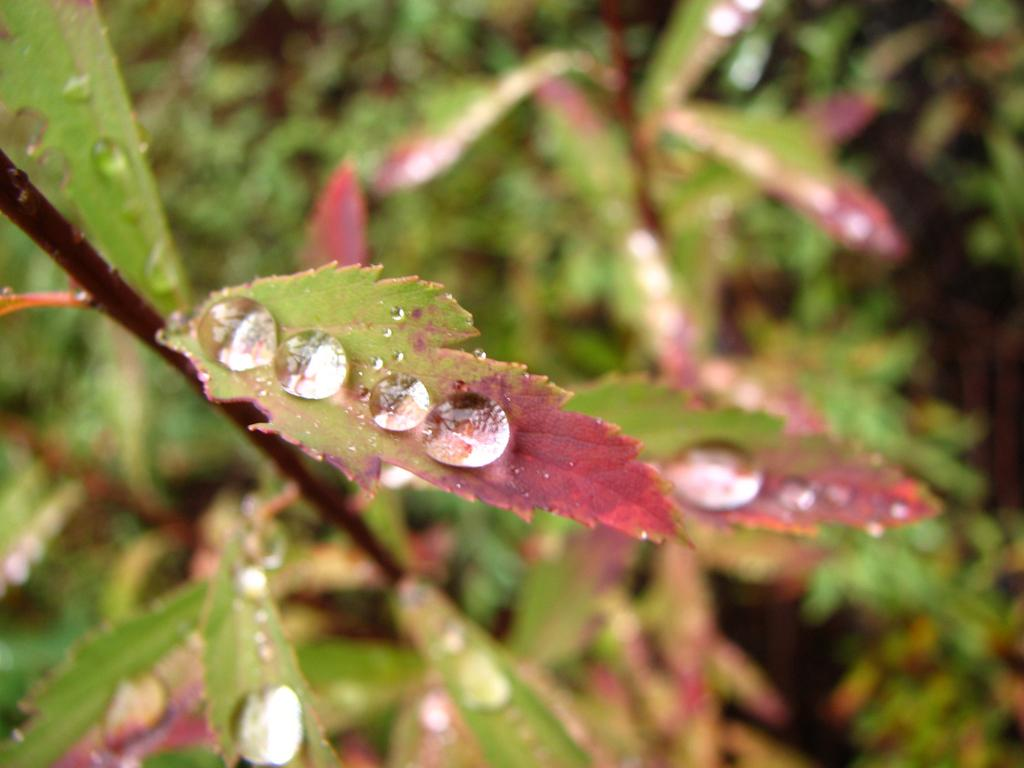What is covering the leaves in the image? There are water bubbles on the leaves in the image. What color is predominant in the background of the image? The background of the image is green. What type of plantation can be seen in the image? There is no plantation present in the image; it features water bubbles on leaves with a green background. What kind of structure is visible in the image? There are no structures visible in the image; it only shows water bubbles on leaves and a green background. 